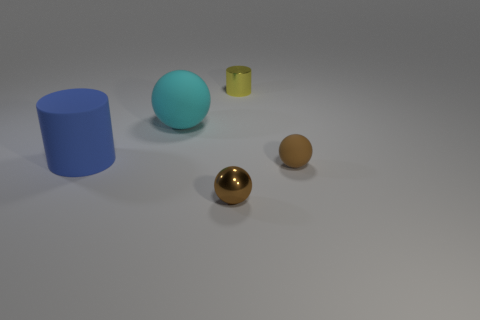Subtract all tiny metallic balls. How many balls are left? 2 Subtract all brown balls. How many balls are left? 1 Subtract all purple cubes. How many cyan spheres are left? 1 Subtract all big blue cylinders. Subtract all big spheres. How many objects are left? 3 Add 4 brown things. How many brown things are left? 6 Add 3 small yellow metallic things. How many small yellow metallic things exist? 4 Add 2 big blue things. How many objects exist? 7 Subtract 0 cyan cylinders. How many objects are left? 5 Subtract all spheres. How many objects are left? 2 Subtract 3 spheres. How many spheres are left? 0 